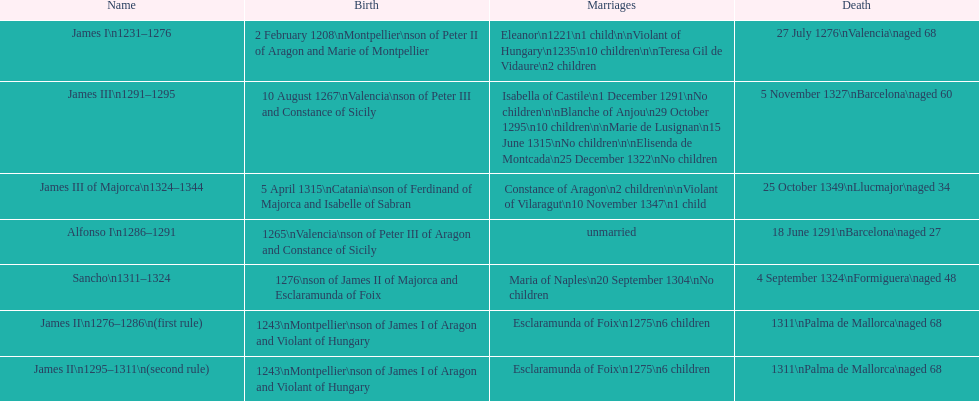Which monarch is listed first? James I 1231-1276. 